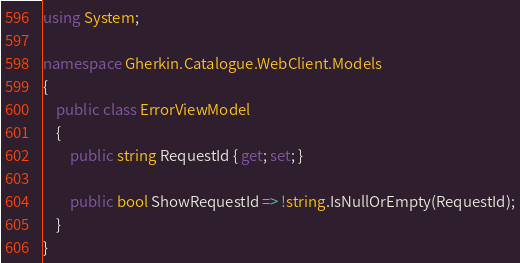<code> <loc_0><loc_0><loc_500><loc_500><_C#_>using System;

namespace Gherkin.Catalogue.WebClient.Models
{
    public class ErrorViewModel
    {
        public string RequestId { get; set; }

        public bool ShowRequestId => !string.IsNullOrEmpty(RequestId);
    }
}
</code> 